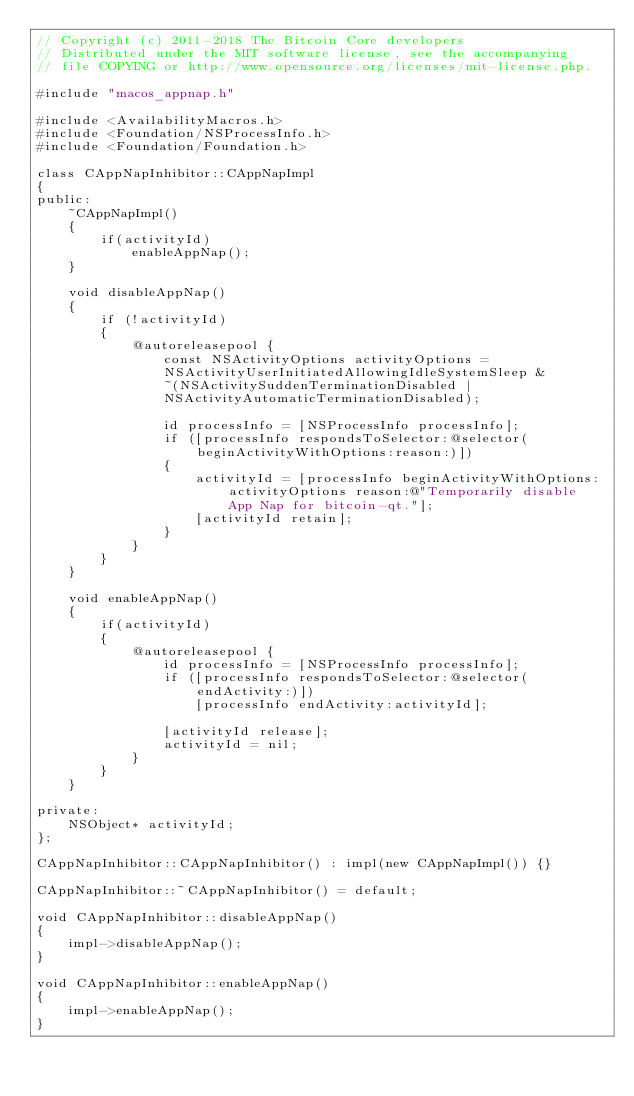<code> <loc_0><loc_0><loc_500><loc_500><_ObjectiveC_>// Copyright (c) 2011-2018 The Bitcoin Core developers
// Distributed under the MIT software license, see the accompanying
// file COPYING or http://www.opensource.org/licenses/mit-license.php.

#include "macos_appnap.h"

#include <AvailabilityMacros.h>
#include <Foundation/NSProcessInfo.h>
#include <Foundation/Foundation.h>

class CAppNapInhibitor::CAppNapImpl
{
public:
    ~CAppNapImpl()
    {
        if(activityId)
            enableAppNap();
    }

    void disableAppNap()
    {
        if (!activityId)
        {
            @autoreleasepool {
                const NSActivityOptions activityOptions =
                NSActivityUserInitiatedAllowingIdleSystemSleep &
                ~(NSActivitySuddenTerminationDisabled |
                NSActivityAutomaticTerminationDisabled);

                id processInfo = [NSProcessInfo processInfo];
                if ([processInfo respondsToSelector:@selector(beginActivityWithOptions:reason:)])
                {
                    activityId = [processInfo beginActivityWithOptions: activityOptions reason:@"Temporarily disable App Nap for bitcoin-qt."];
                    [activityId retain];
                }
            }
        }
    }

    void enableAppNap()
    {
        if(activityId)
        {
            @autoreleasepool {
                id processInfo = [NSProcessInfo processInfo];
                if ([processInfo respondsToSelector:@selector(endActivity:)])
                    [processInfo endActivity:activityId];

                [activityId release];
                activityId = nil;
            }
        }
    }

private:
    NSObject* activityId;
};

CAppNapInhibitor::CAppNapInhibitor() : impl(new CAppNapImpl()) {}

CAppNapInhibitor::~CAppNapInhibitor() = default;

void CAppNapInhibitor::disableAppNap()
{
    impl->disableAppNap();
}

void CAppNapInhibitor::enableAppNap()
{
    impl->enableAppNap();
}</code> 